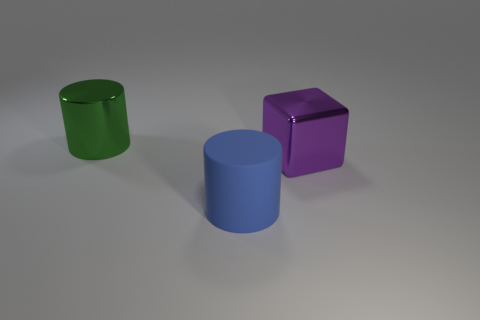Add 2 green cylinders. How many objects exist? 5 Subtract all cylinders. How many objects are left? 1 Add 2 small yellow blocks. How many small yellow blocks exist? 2 Subtract 0 brown cylinders. How many objects are left? 3 Subtract all cyan matte cylinders. Subtract all big shiny cubes. How many objects are left? 2 Add 1 metallic cylinders. How many metallic cylinders are left? 2 